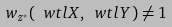<formula> <loc_0><loc_0><loc_500><loc_500>w _ { z ^ { * } } ( \ w t l X , \ w t l Y ) \neq 1</formula> 